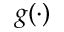Convert formula to latex. <formula><loc_0><loc_0><loc_500><loc_500>g ( \cdot )</formula> 